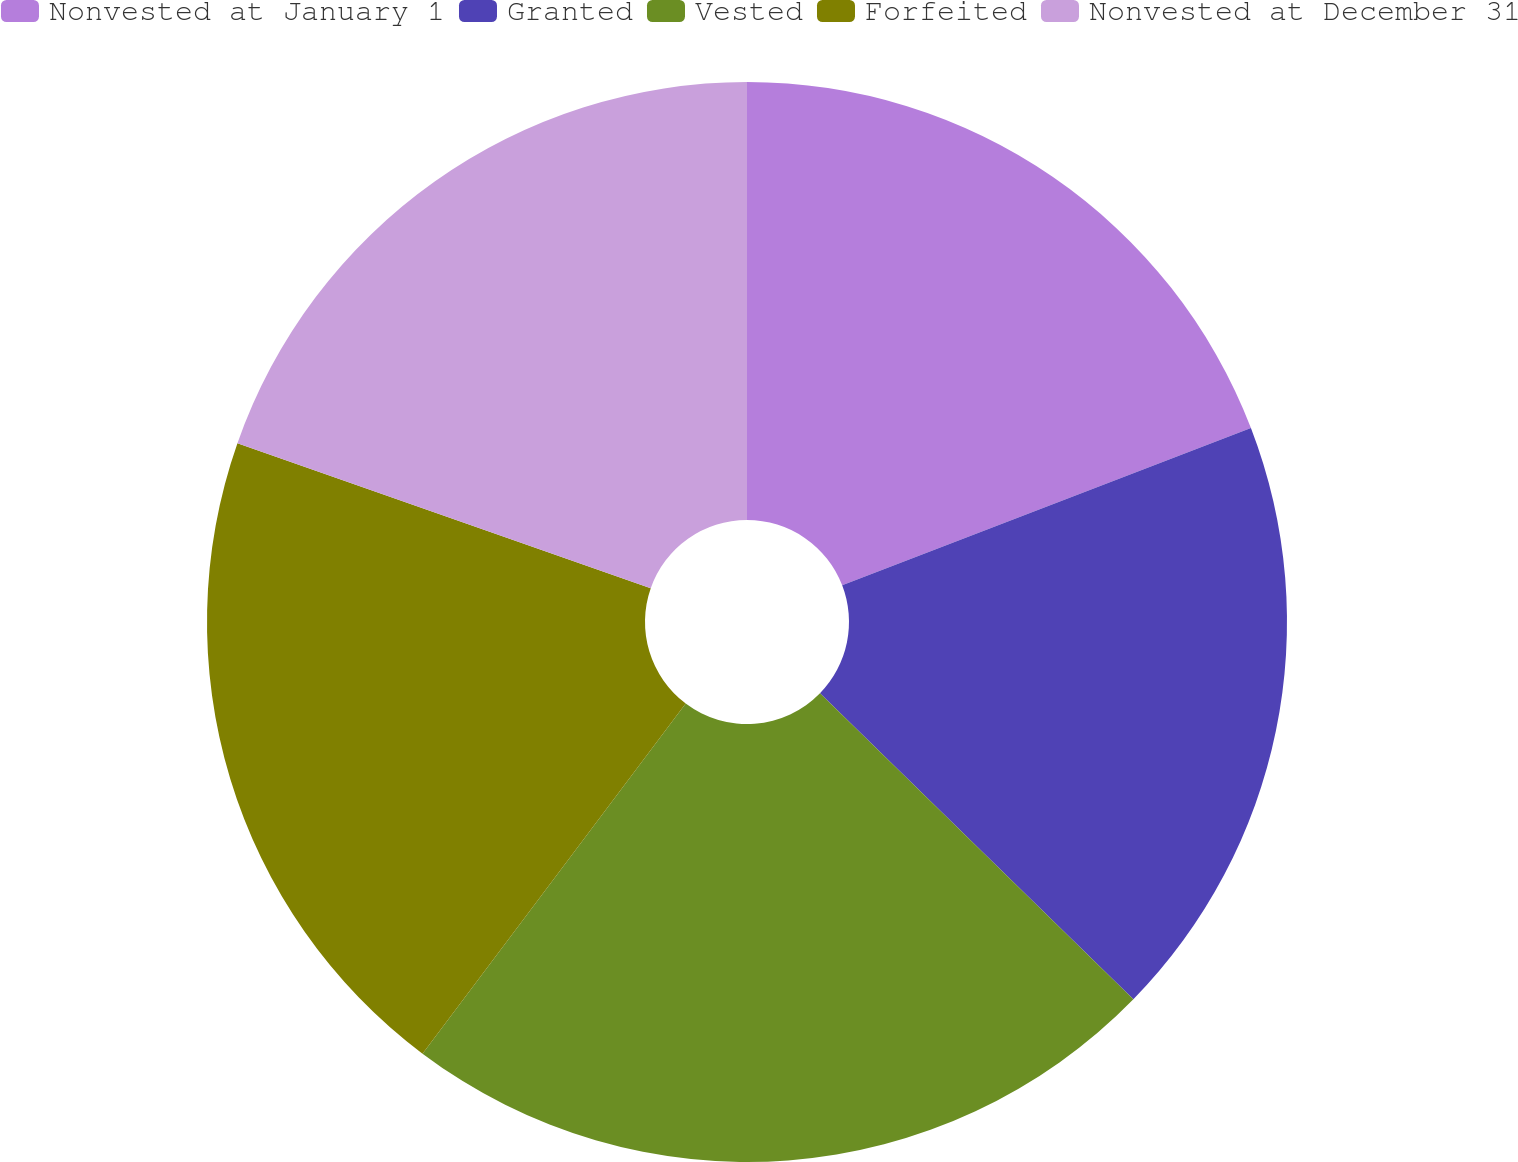Convert chart. <chart><loc_0><loc_0><loc_500><loc_500><pie_chart><fcel>Nonvested at January 1<fcel>Granted<fcel>Vested<fcel>Forfeited<fcel>Nonvested at December 31<nl><fcel>19.15%<fcel>18.16%<fcel>22.95%<fcel>20.11%<fcel>19.63%<nl></chart> 